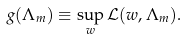Convert formula to latex. <formula><loc_0><loc_0><loc_500><loc_500>g ( \Lambda _ { m } ) \equiv \sup _ { w } \mathcal { L } ( w , \Lambda _ { m } ) .</formula> 